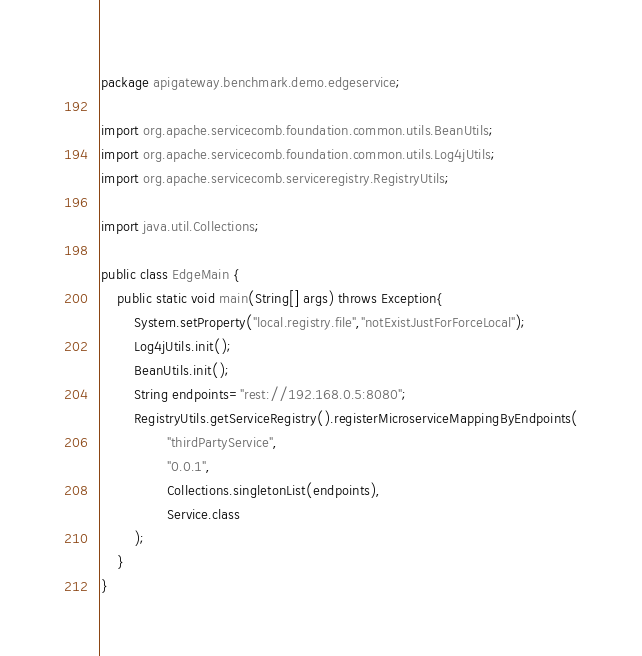<code> <loc_0><loc_0><loc_500><loc_500><_Java_>package apigateway.benchmark.demo.edgeservice;

import org.apache.servicecomb.foundation.common.utils.BeanUtils;
import org.apache.servicecomb.foundation.common.utils.Log4jUtils;
import org.apache.servicecomb.serviceregistry.RegistryUtils;

import java.util.Collections;

public class EdgeMain {
    public static void main(String[] args) throws Exception{
        System.setProperty("local.registry.file","notExistJustForForceLocal");
        Log4jUtils.init();
        BeanUtils.init();
        String endpoints="rest://192.168.0.5:8080";
        RegistryUtils.getServiceRegistry().registerMicroserviceMappingByEndpoints(
                "thirdPartyService",
                "0.0.1",
                Collections.singletonList(endpoints),
                Service.class
        );
    }
}
</code> 